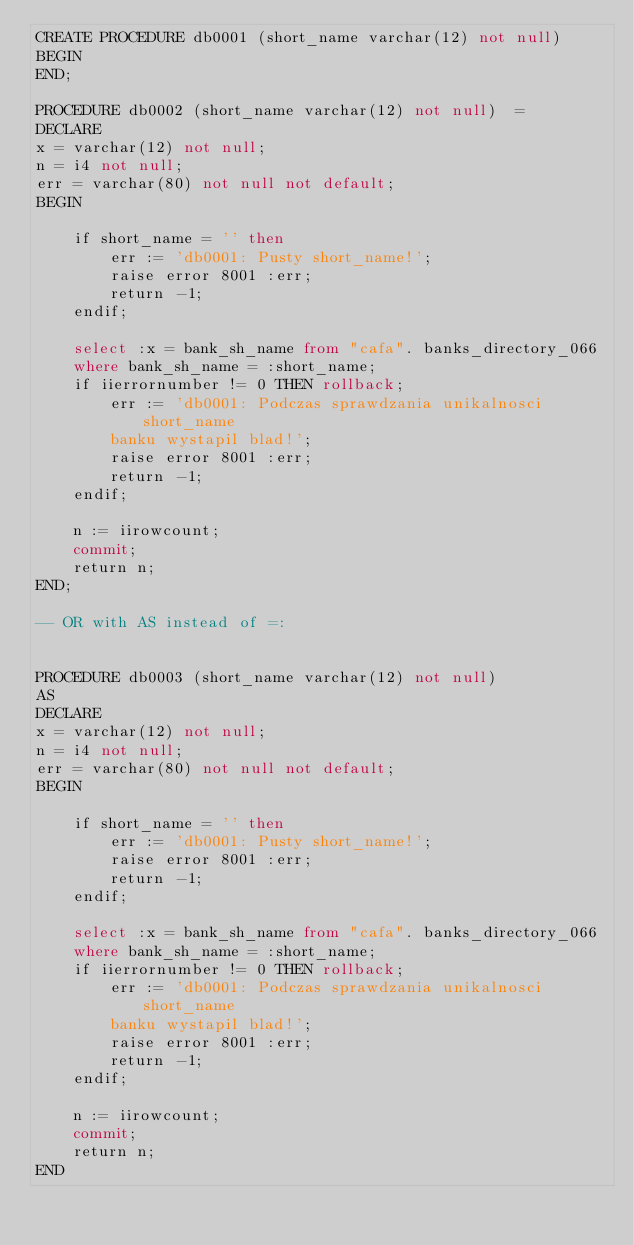Convert code to text. <code><loc_0><loc_0><loc_500><loc_500><_SQL_>CREATE PROCEDURE db0001 (short_name varchar(12) not null)  
BEGIN
END;

PROCEDURE db0002 (short_name varchar(12) not null)  =
DECLARE
x = varchar(12) not null; 
n = i4 not null; 
err = varchar(80) not null not default; 
BEGIN 

    if short_name = '' then 
        err := 'db0001: Pusty short_name!'; 
        raise error 8001 :err; 
        return -1; 
    endif; 

    select :x = bank_sh_name from "cafa". banks_directory_066 
    where bank_sh_name = :short_name; 
    if iierrornumber != 0 THEN rollback; 
        err := 'db0001: Podczas sprawdzania unikalnosci short_name 
        banku wystapil blad!'; 
        raise error 8001 :err; 
        return -1; 
    endif; 

    n := iirowcount; 
    commit; 
    return n; 
END;  

-- OR with AS instead of =:


PROCEDURE db0003 (short_name varchar(12) not null)  
AS
DECLARE
x = varchar(12) not null; 
n = i4 not null; 
err = varchar(80) not null not default; 
BEGIN 

    if short_name = '' then 
        err := 'db0001: Pusty short_name!'; 
        raise error 8001 :err; 
        return -1; 
    endif; 

    select :x = bank_sh_name from "cafa". banks_directory_066 
    where bank_sh_name = :short_name; 
    if iierrornumber != 0 THEN rollback; 
        err := 'db0001: Podczas sprawdzania unikalnosci short_name 
        banku wystapil blad!'; 
        raise error 8001 :err; 
        return -1; 
    endif; 

    n := iirowcount; 
    commit; 
    return n; 
END  


</code> 